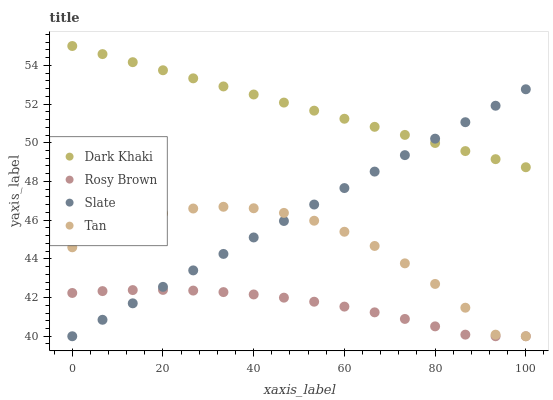Does Rosy Brown have the minimum area under the curve?
Answer yes or no. Yes. Does Dark Khaki have the maximum area under the curve?
Answer yes or no. Yes. Does Slate have the minimum area under the curve?
Answer yes or no. No. Does Slate have the maximum area under the curve?
Answer yes or no. No. Is Slate the smoothest?
Answer yes or no. Yes. Is Tan the roughest?
Answer yes or no. Yes. Is Rosy Brown the smoothest?
Answer yes or no. No. Is Rosy Brown the roughest?
Answer yes or no. No. Does Slate have the lowest value?
Answer yes or no. Yes. Does Dark Khaki have the highest value?
Answer yes or no. Yes. Does Slate have the highest value?
Answer yes or no. No. Is Tan less than Dark Khaki?
Answer yes or no. Yes. Is Dark Khaki greater than Tan?
Answer yes or no. Yes. Does Rosy Brown intersect Slate?
Answer yes or no. Yes. Is Rosy Brown less than Slate?
Answer yes or no. No. Is Rosy Brown greater than Slate?
Answer yes or no. No. Does Tan intersect Dark Khaki?
Answer yes or no. No. 